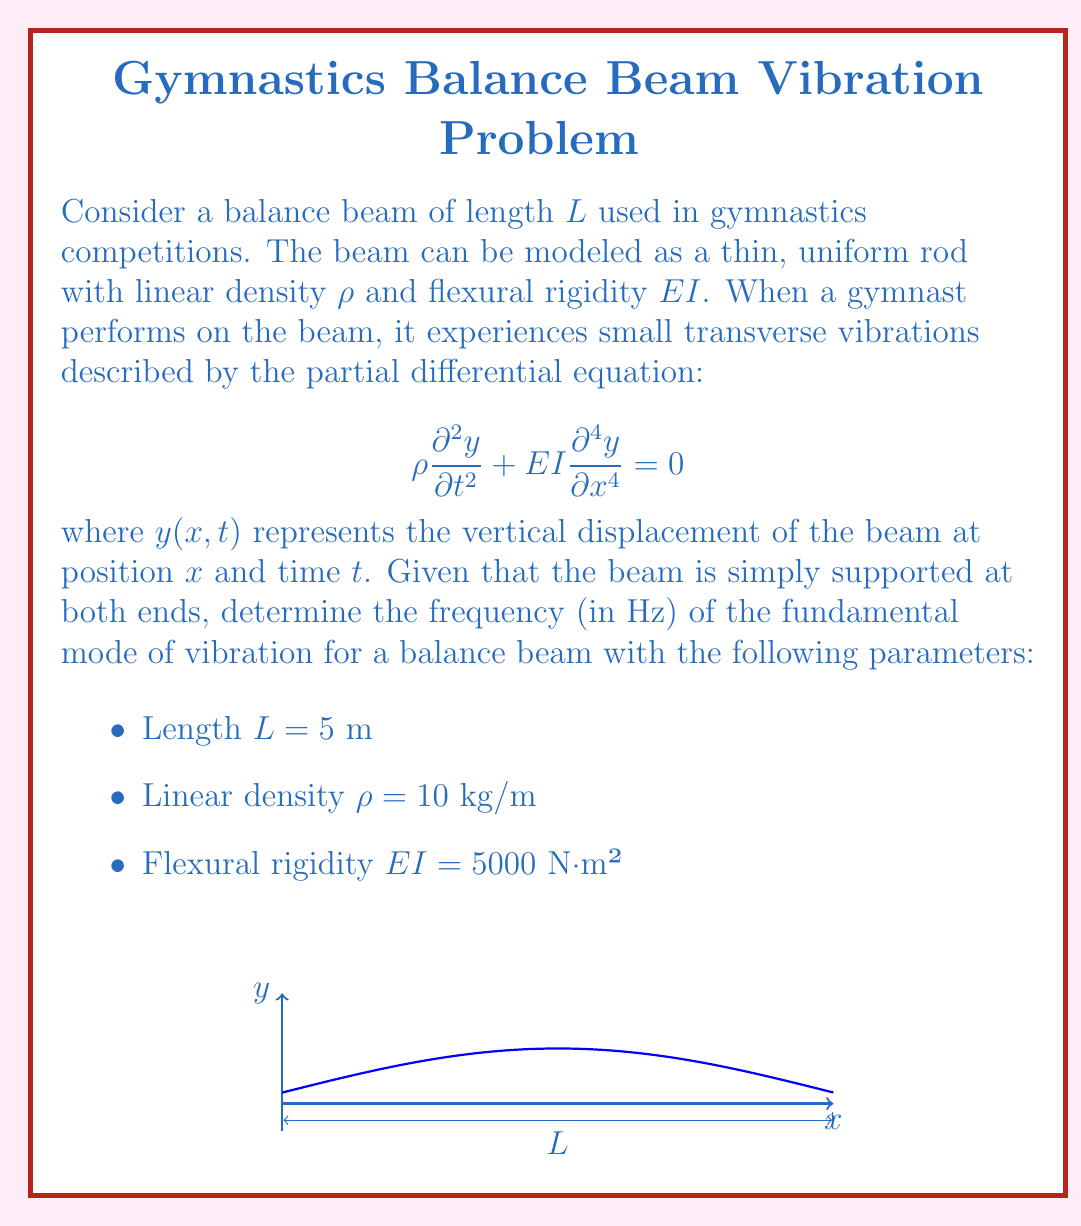What is the answer to this math problem? To solve this problem, we'll follow these steps:

1) For a simply supported beam, the boundary conditions are:
   $y(0,t) = y(L,t) = 0$ and $\frac{\partial^2 y}{\partial x^2}(0,t) = \frac{\partial^2 y}{\partial x^2}(L,t) = 0$

2) The general solution for the vibration modes is of the form:
   $y(x,t) = X(x)(A\cos(\omega t) + B\sin(\omega t))$

3) Substituting this into the PDE, we get:
   $-\rho\omega^2 X + EI\frac{d^4X}{dx^4} = 0$

4) The spatial function $X(x)$ that satisfies the boundary conditions is:
   $X(x) = C\sin(\frac{n\pi x}{L})$, where $n = 1, 2, 3, ...$

5) Substituting this into the equation from step 3:
   $\rho\omega^2 = EI(\frac{n\pi}{L})^4$

6) Solving for $\omega$:
   $\omega = \frac{n^2\pi^2}{L^2}\sqrt{\frac{EI}{\rho}}$

7) The frequency $f$ is related to $\omega$ by $f = \frac{\omega}{2\pi}$

8) For the fundamental mode, $n = 1$. Substituting the given values:
   $f = \frac{1}{2\pi} \cdot \frac{\pi^2}{5^2}\sqrt{\frac{5000}{10}} = \frac{\pi}{50}\sqrt{500} \approx 1.40$ Hz

Therefore, the frequency of the fundamental mode of vibration is approximately 1.40 Hz.
Answer: 1.40 Hz 